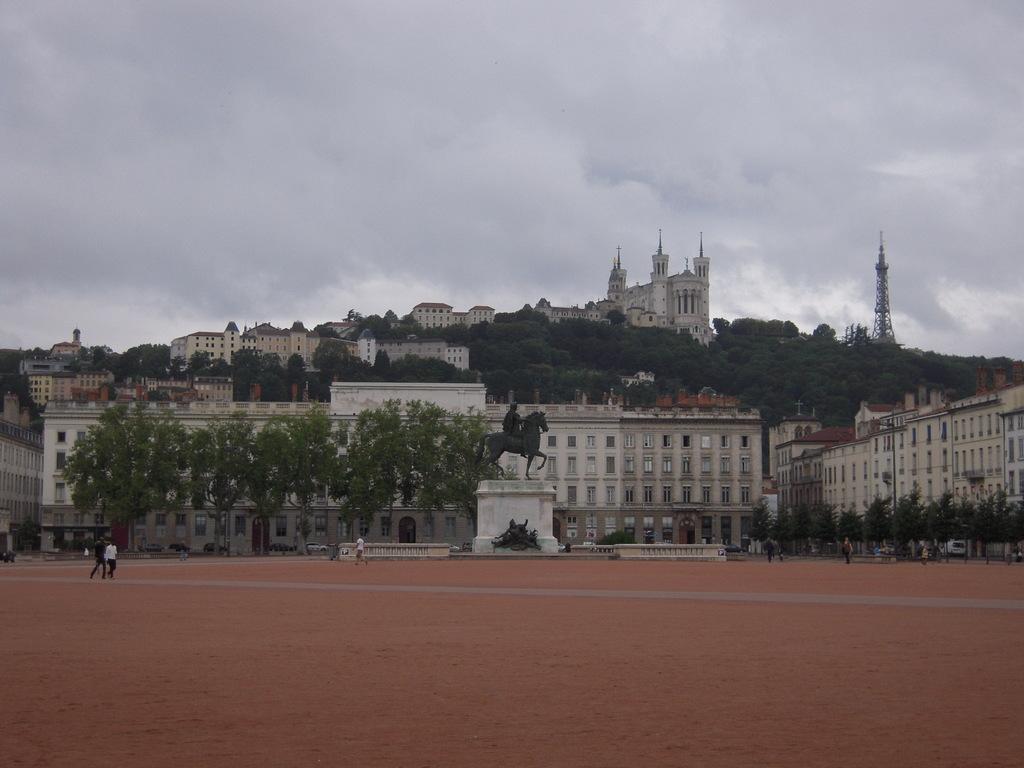Describe this image in one or two sentences. In this image I can see the ground, few persons standing in the ground, a statue of a person sitting on a horse which is black in color, few trees and few buildings. In the background I can see a mountain, a tower, few buildings on the mountains, few trees and the sky. 